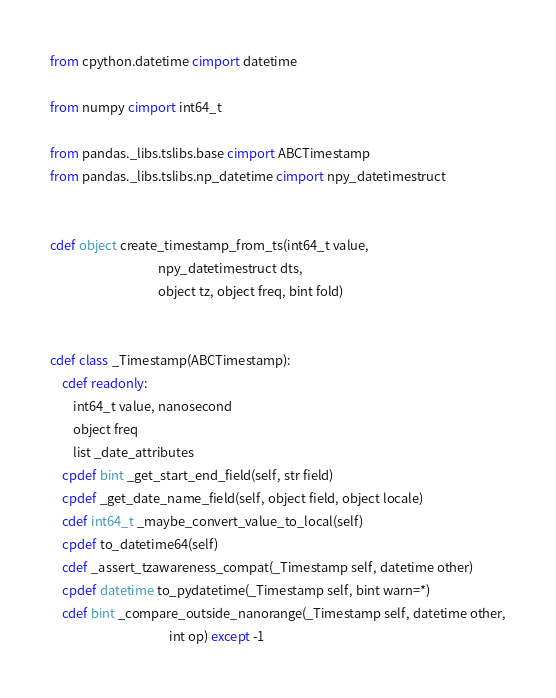Convert code to text. <code><loc_0><loc_0><loc_500><loc_500><_Cython_>from cpython.datetime cimport datetime

from numpy cimport int64_t

from pandas._libs.tslibs.base cimport ABCTimestamp
from pandas._libs.tslibs.np_datetime cimport npy_datetimestruct


cdef object create_timestamp_from_ts(int64_t value,
                                     npy_datetimestruct dts,
                                     object tz, object freq, bint fold)


cdef class _Timestamp(ABCTimestamp):
    cdef readonly:
        int64_t value, nanosecond
        object freq
        list _date_attributes
    cpdef bint _get_start_end_field(self, str field)
    cpdef _get_date_name_field(self, object field, object locale)
    cdef int64_t _maybe_convert_value_to_local(self)
    cpdef to_datetime64(self)
    cdef _assert_tzawareness_compat(_Timestamp self, datetime other)
    cpdef datetime to_pydatetime(_Timestamp self, bint warn=*)
    cdef bint _compare_outside_nanorange(_Timestamp self, datetime other,
                                         int op) except -1
</code> 